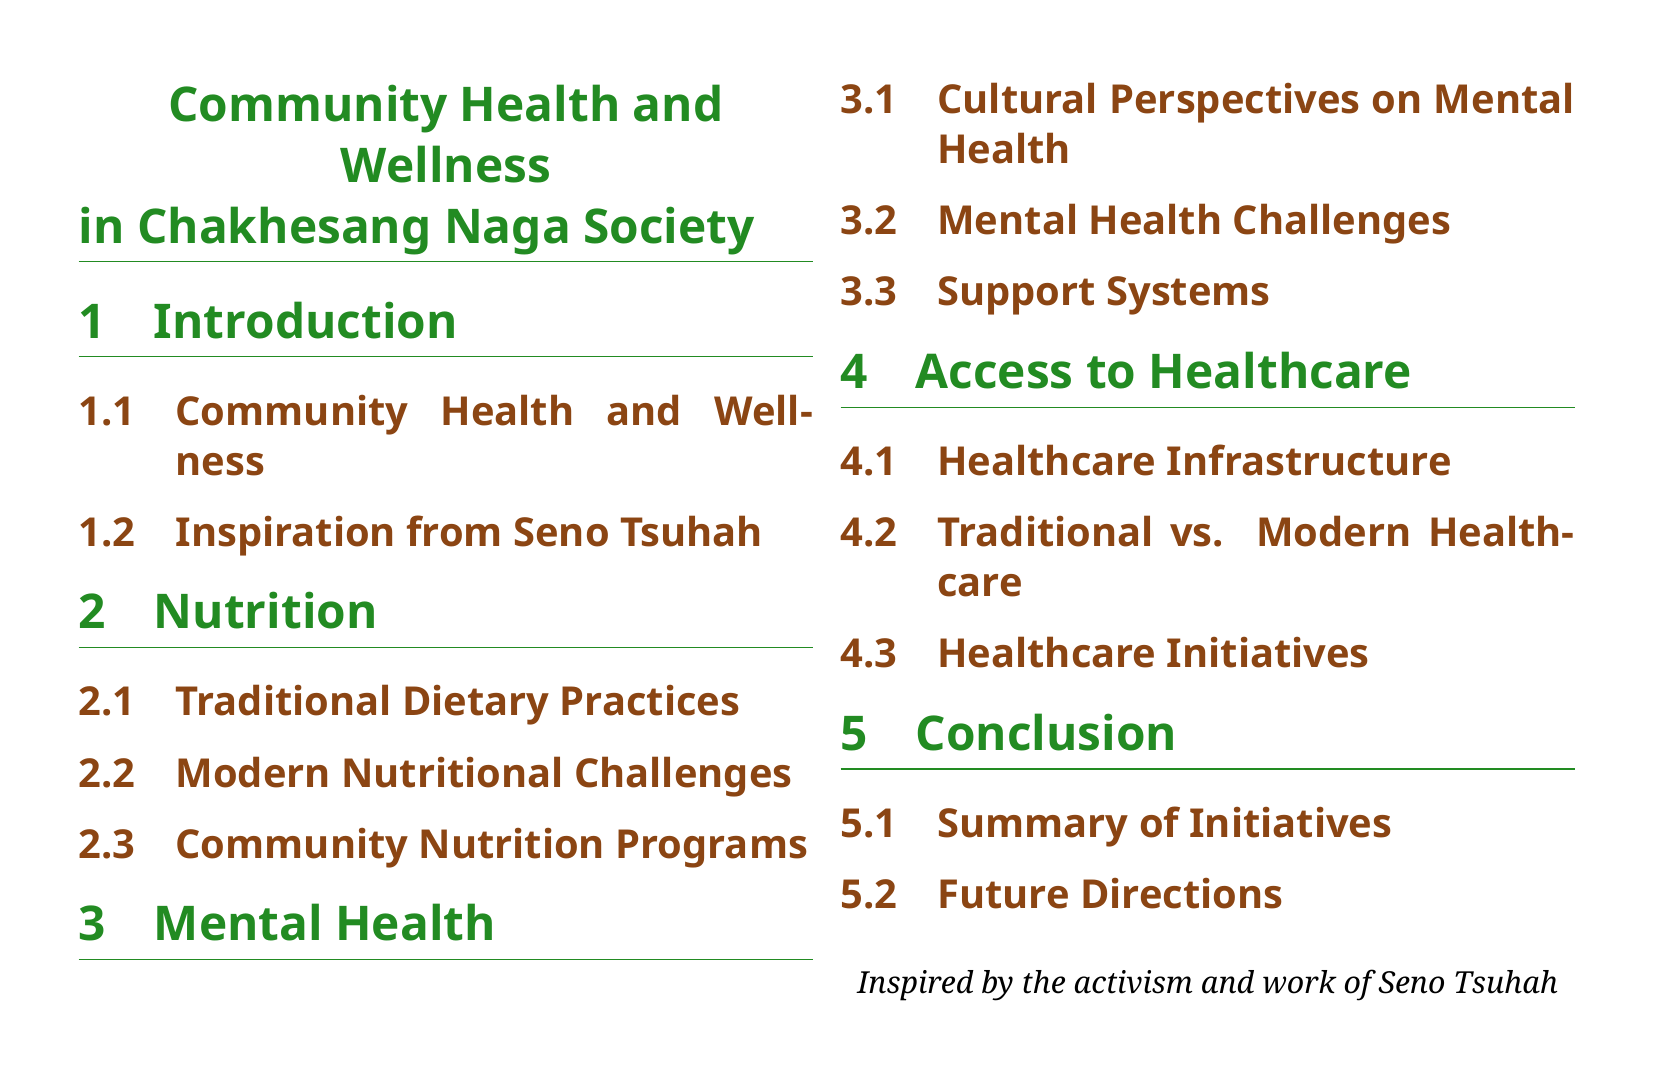what is the title of the document? The title of the document is explicitly stated at the top.
Answer: Community Health and Wellness in Chakhesang Naga Society who is the source of inspiration mentioned in the document? The document highlights a particular individual's work that inspired the content.
Answer: Seno Tsuhah how many sections are listed in the document? The number of sections can be counted from the outline provided in the document's structure.
Answer: 5 what are the main focus areas of community health discussed? The document summarizes the key themes in the sections dedicated to community health.
Answer: nutrition, mental health, access to healthcare which subsection discusses traditional dietary practices? The subsection heading related to dietary practices indicates where this topic is covered.
Answer: Traditional Dietary Practices what color is used for section titles? The document specifies the color used for section titles in its formatting.
Answer: nagagreen what does the conclusion section summarize? The conclusion part of the document aims to encapsulate previous discussions.
Answer: Summary of Initiatives what is mentioned in the traditional vs. modern healthcare subsection? The healthcare subsection indicates the content focusing on these healthcare systems.
Answer: Traditional vs. Modern Healthcare what is the primary theme of the mental health section? The section on mental health encompasses its cultural perspectives and challenges.
Answer: Cultural Perspectives on Mental Health 